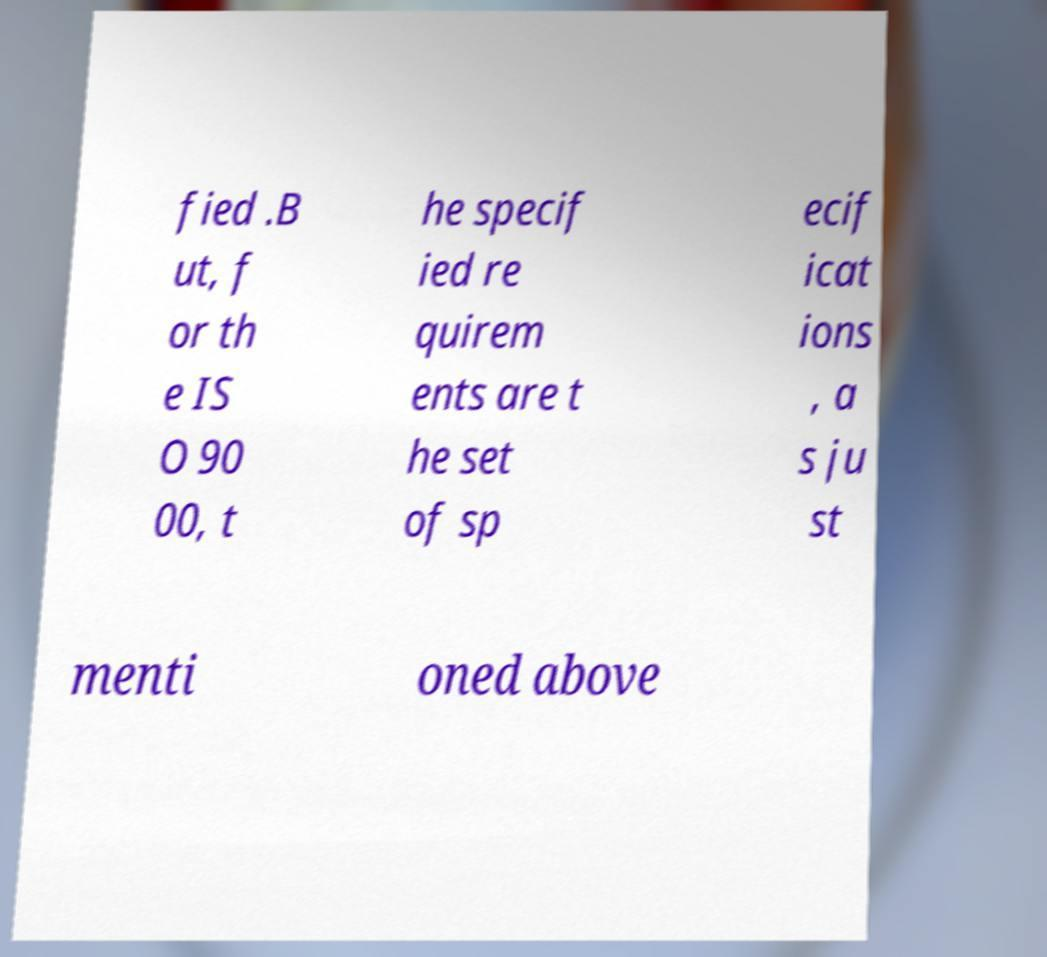There's text embedded in this image that I need extracted. Can you transcribe it verbatim? fied .B ut, f or th e IS O 90 00, t he specif ied re quirem ents are t he set of sp ecif icat ions , a s ju st menti oned above 